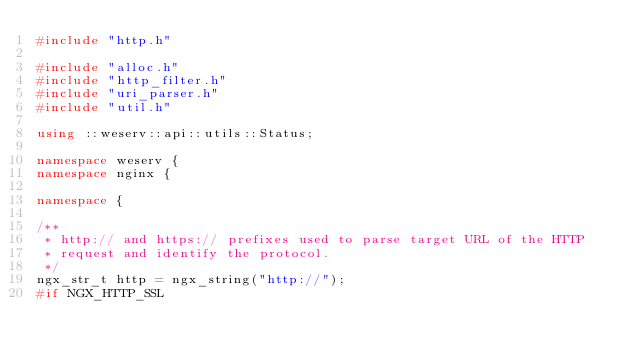Convert code to text. <code><loc_0><loc_0><loc_500><loc_500><_C++_>#include "http.h"

#include "alloc.h"
#include "http_filter.h"
#include "uri_parser.h"
#include "util.h"

using ::weserv::api::utils::Status;

namespace weserv {
namespace nginx {

namespace {

/**
 * http:// and https:// prefixes used to parse target URL of the HTTP
 * request and identify the protocol.
 */
ngx_str_t http = ngx_string("http://");
#if NGX_HTTP_SSL</code> 